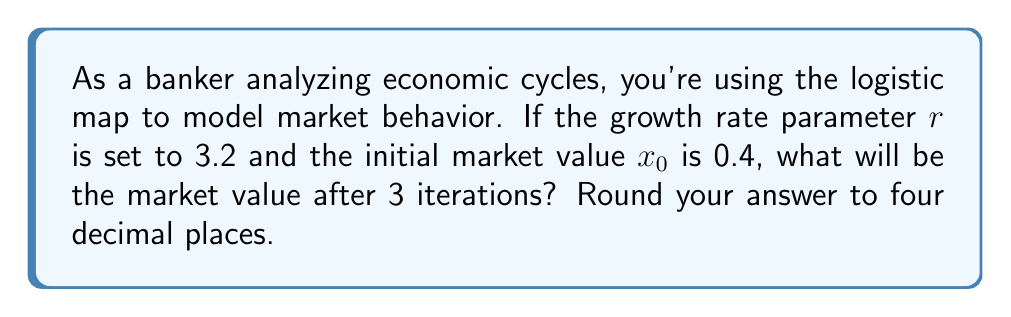Show me your answer to this math problem. To solve this problem, we'll use the logistic map equation and iterate it three times. The logistic map is given by:

$$x_{n+1} = rx_n(1-x_n)$$

Where:
$r$ = growth rate parameter (3.2 in this case)
$x_n$ = market value at iteration n
$x_0$ = initial market value (0.4 in this case)

Let's calculate step by step:

1. First iteration (n = 0 to n = 1):
   $$x_1 = 3.2 \cdot 0.4 \cdot (1-0.4) = 3.2 \cdot 0.4 \cdot 0.6 = 0.768$$

2. Second iteration (n = 1 to n = 2):
   $$x_2 = 3.2 \cdot 0.768 \cdot (1-0.768) = 3.2 \cdot 0.768 \cdot 0.232 = 0.570163$$

3. Third iteration (n = 2 to n = 3):
   $$x_3 = 3.2 \cdot 0.570163 \cdot (1-0.570163) = 3.2 \cdot 0.570163 \cdot 0.429837 = 0.784199$$

Rounding to four decimal places, we get 0.7842.
Answer: 0.7842 